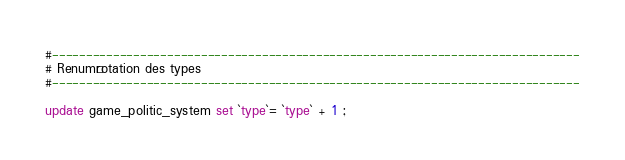<code> <loc_0><loc_0><loc_500><loc_500><_SQL_>#------------------------------------------------------------------------------
# Renumérotation des types
#------------------------------------------------------------------------------

update game_politic_system set `type`= `type` + 1 ;</code> 